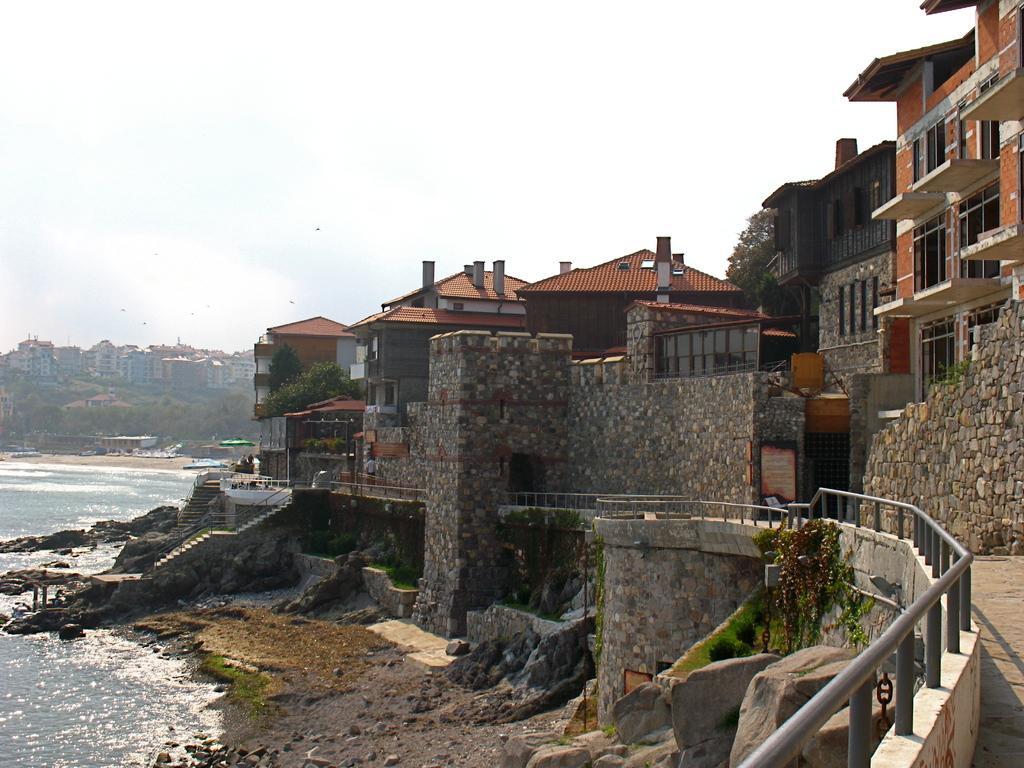In one or two sentences, can you explain what this image depicts? In the foreground of this image, there is a railing, path, rocks, land, water and few buildings. In the background, there are buildings, trees, water, birds and the sky. 